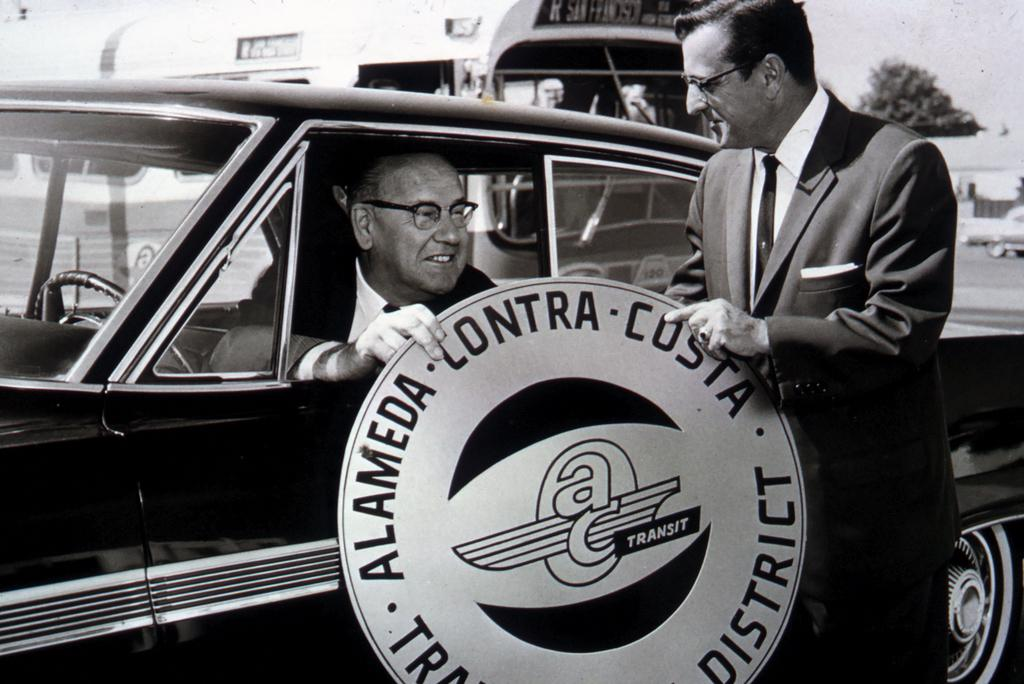What is the man in the car doing in the image? There is a man sitting in a car on the left side of the image. What is the man on the right side of the image doing? There is a man standing on the right side of the image. What can be seen behind the standing man? There is a tree visible behind the standing man. What type of badge is the man in the car wearing in the image? There is no mention of a badge in the image, so it cannot be determined if the man in the car is wearing one. What type of canvas is visible in the image? There is no canvas present in the image. 